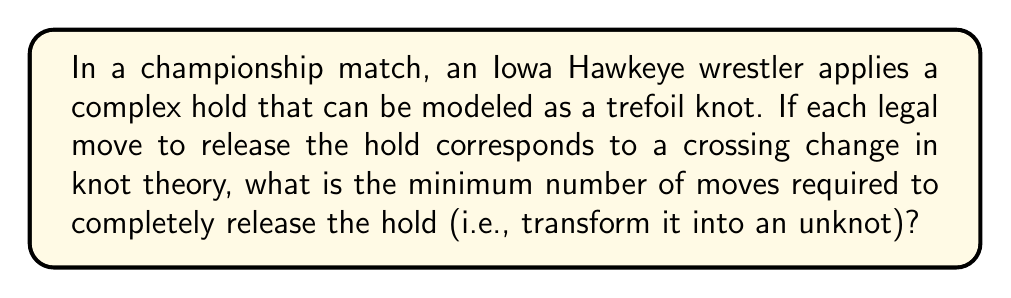Give your solution to this math problem. Let's approach this step-by-step:

1) The trefoil knot is one of the simplest non-trivial knots in knot theory.

2) In knot theory, the unknotting number of a knot is the minimum number of crossing changes required to transform the knot into an unknot.

3) For the trefoil knot, we can visualize it as follows:

   [asy]
   import geometry;
   
   path p = (0,0)..(-1,1)..(0,2)..(1,1)..(0,0);
   path q = (0,0)..(1,-1)..(0,-2)..(-1,-1)..(0,0);
   
   draw(p, blue);
   draw(q, blue);
   
   dot((0,0), red);
   dot((0,2), red);
   dot((0,-2), red);
   [/asy]

4) The trefoil knot has a crossing number of 3, meaning it has three crossings in its minimal diagram.

5) However, the unknotting number is not always equal to the crossing number.

6) For the trefoil knot, it can be proven that the unknotting number is 1.

7) This means that changing any one of the three crossings in the trefoil knot will result in an unknot.

8) Mathematically, we can express the unknotting number of the trefoil knot as:

   $$u(T) = 1$$

   where $u$ represents the unknotting number and $T$ represents the trefoil knot.

9) In the context of wrestling, this means that a single legal move (corresponding to a crossing change) is sufficient to release the hold completely.
Answer: 1 